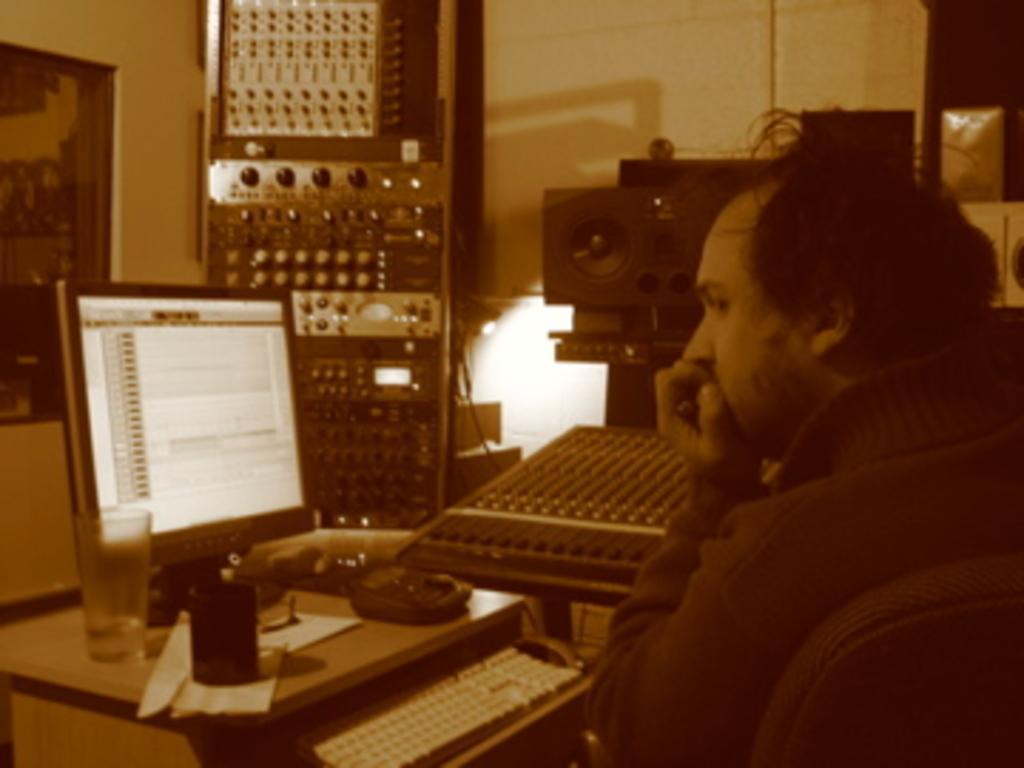Can you describe this image briefly? On the right side, there is a person sitting on a chair in front of a table on which, there is a monitor, glass and other objects. In the background, there are other devices arranged and there is a poster on the wall. 